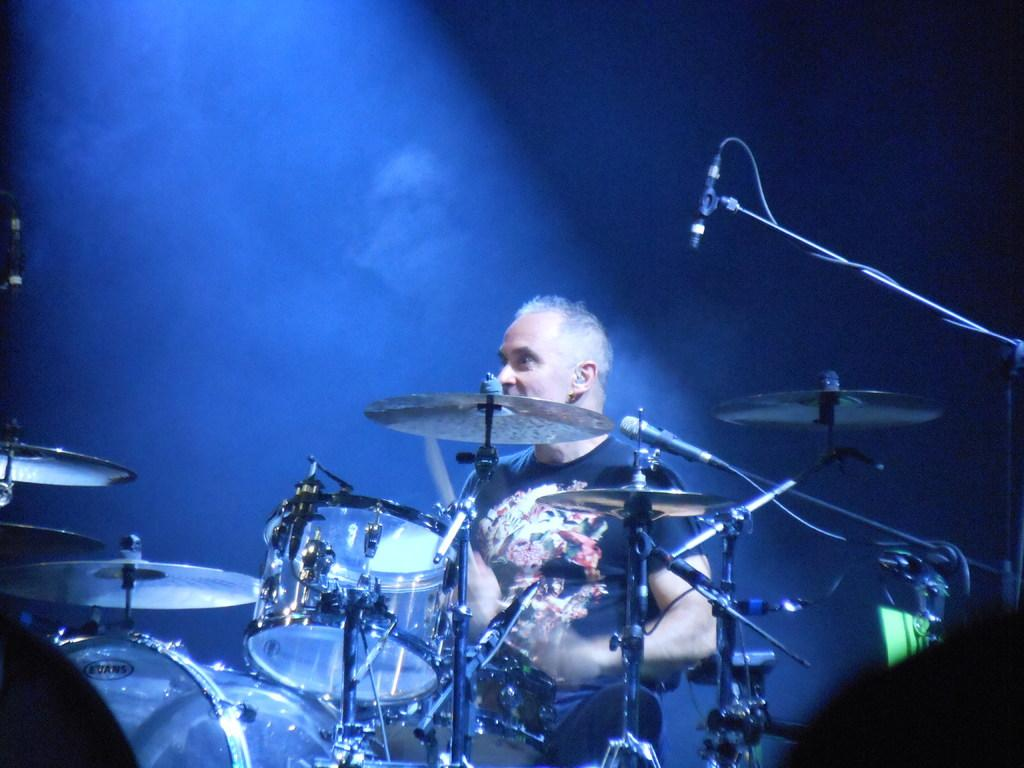What is the main activity being performed in the image? There is a person playing drums in the image. What objects are present to amplify sound? There are microphones in the image. How would you describe the lighting in the image? The background of the image is dark. How many eggs are visible on the drum set in the image? There are no eggs present on the drum set in the image. 